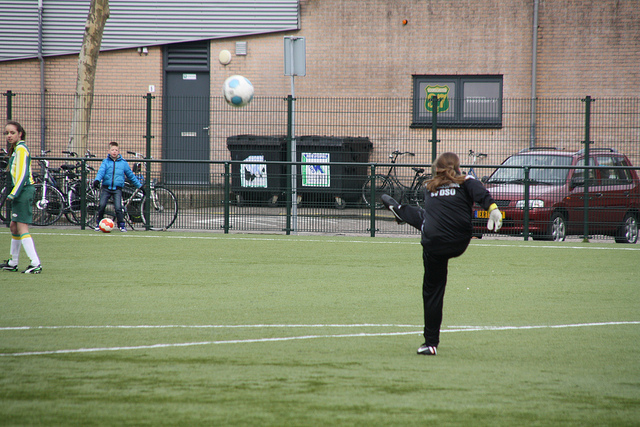<image>Where could a person get snacks? I am not sure. A person could get snacks at a store, shop, building, food truck, or from a vendor. Where could a person get snacks? I don't know where a person could get snacks. It could be a store, shop, building, food truck, or vendor. 